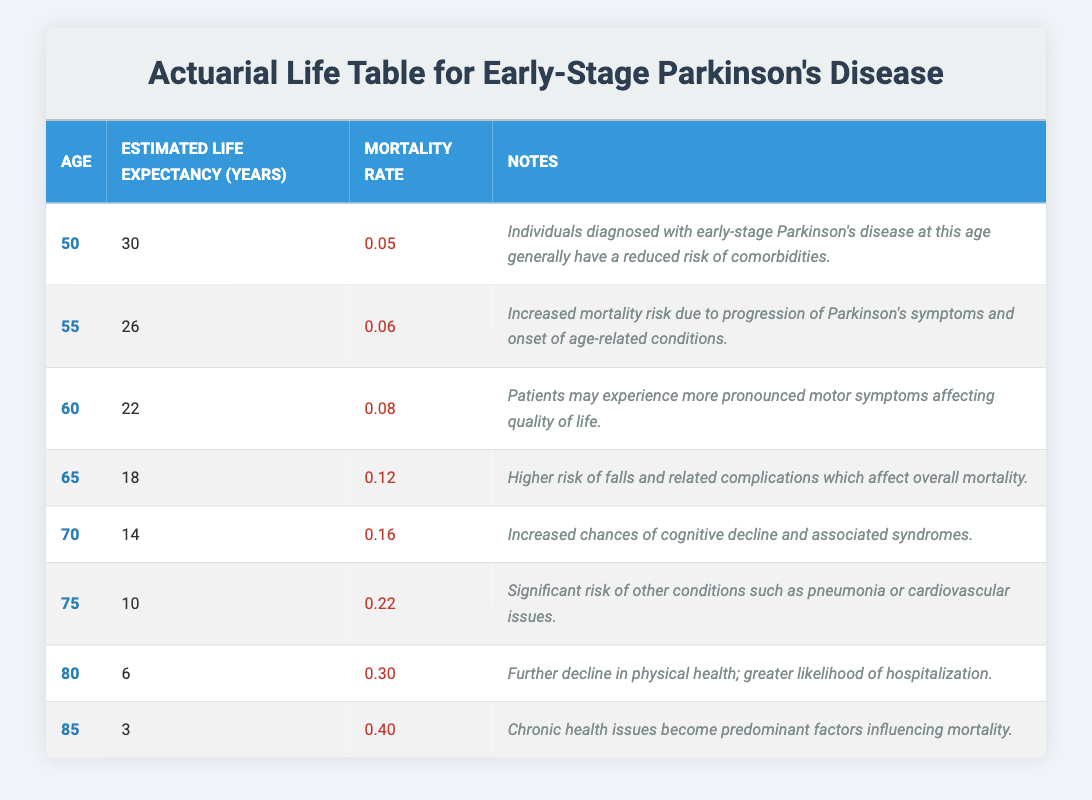What is the estimated life expectancy for an individual diagnosed with early-stage Parkinson's disease at age 60? The table lists the estimated life expectancy for individuals at various ages, with the specific entry for age 60 showing an estimated life expectancy of 22 years.
Answer: 22 years What is the mortality rate for individuals diagnosed with early-stage Parkinson's disease at age 75? The table contains a specific entry for age 75 that indicates a mortality rate of 0.22.
Answer: 0.22 How much does the estimated life expectancy decrease from age 50 to age 70? From the table, the estimated life expectancies are 30 years at age 50 and 14 years at age 70. To find the decrease, we subtract: 30 - 14 = 16 years.
Answer: 16 years Is the estimated life expectancy at age 85 less than 5 years? The table shows that the estimated life expectancy at age 85 is 3 years, which is indeed less than 5 years.
Answer: Yes What is the average estimated life expectancy for individuals aged 60 to 80 with early-stage Parkinson's disease? The estimated life expectancies from the table for ages 60, 65, 70, 75, and 80 are 22, 18, 14, 10, and 6 years respectively. We calculate the average: (22 + 18 + 14 + 10 + 6) / 5 = 70 / 5 = 14 years.
Answer: 14 years Which age group has the highest mortality rate in the table? Reviewing the mortality rates listed in the table, the highest rate is found at age 85, at 0.40, compared to other age groups.
Answer: Age 85 How does the mortality rate change from age 55 to age 65? The table indicates that the mortality rate at age 55 is 0.06 and at age 65 is 0.12. The change can be calculated by subtracting: 0.12 - 0.06 = 0.06, indicating an increase.
Answer: Increased by 0.06 Do individuals aged 70 and older have an estimated life expectancy of less than 15 years? According to the table, individuals at age 70 have an estimated life expectancy of 14 years, age 75 have 10 years, age 80 have 6 years, and age 85 have 3 years. All are less than 15 years.
Answer: Yes 